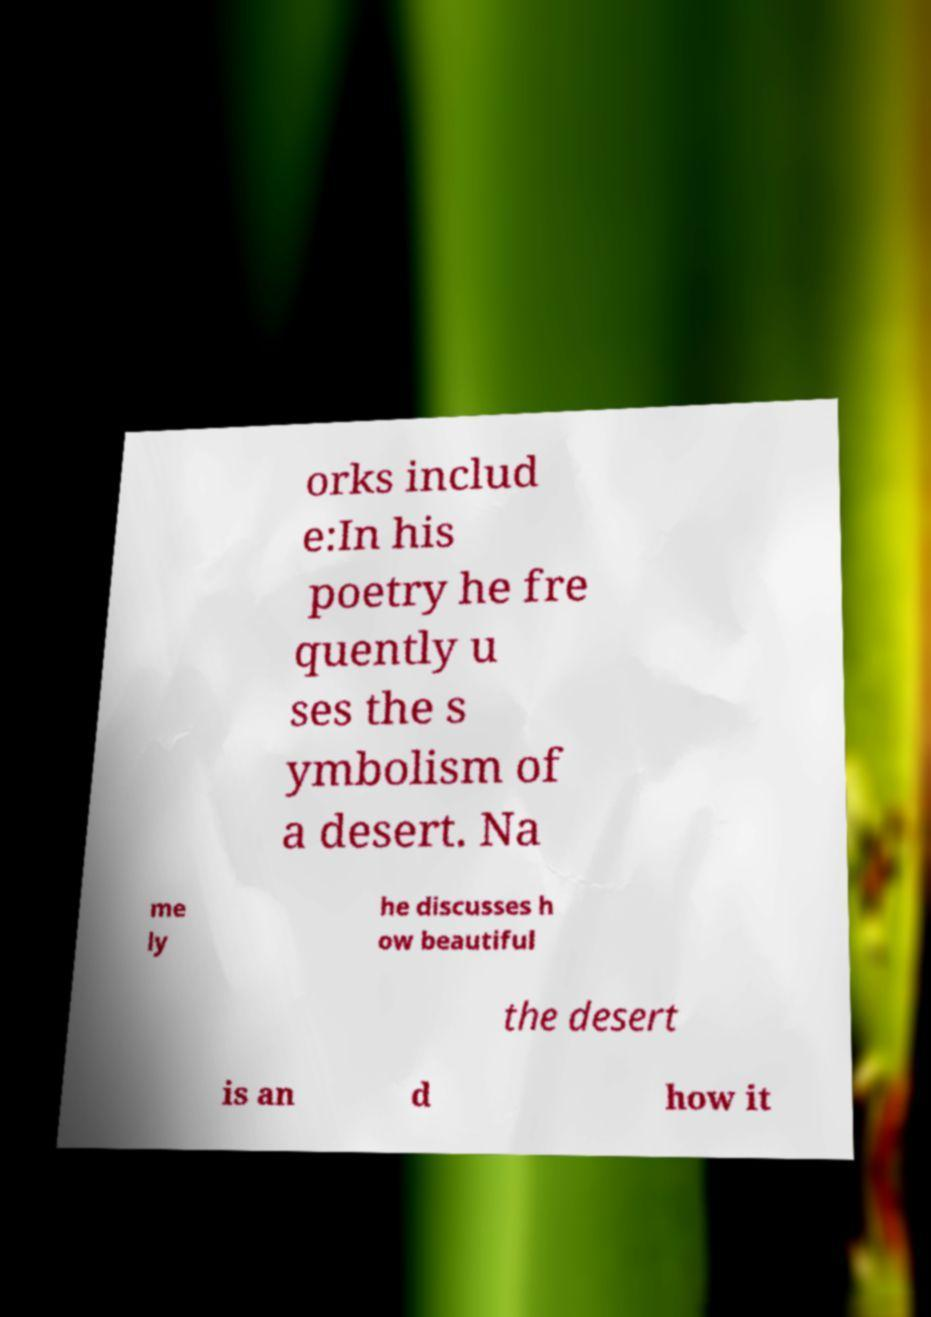I need the written content from this picture converted into text. Can you do that? orks includ e:In his poetry he fre quently u ses the s ymbolism of a desert. Na me ly he discusses h ow beautiful the desert is an d how it 